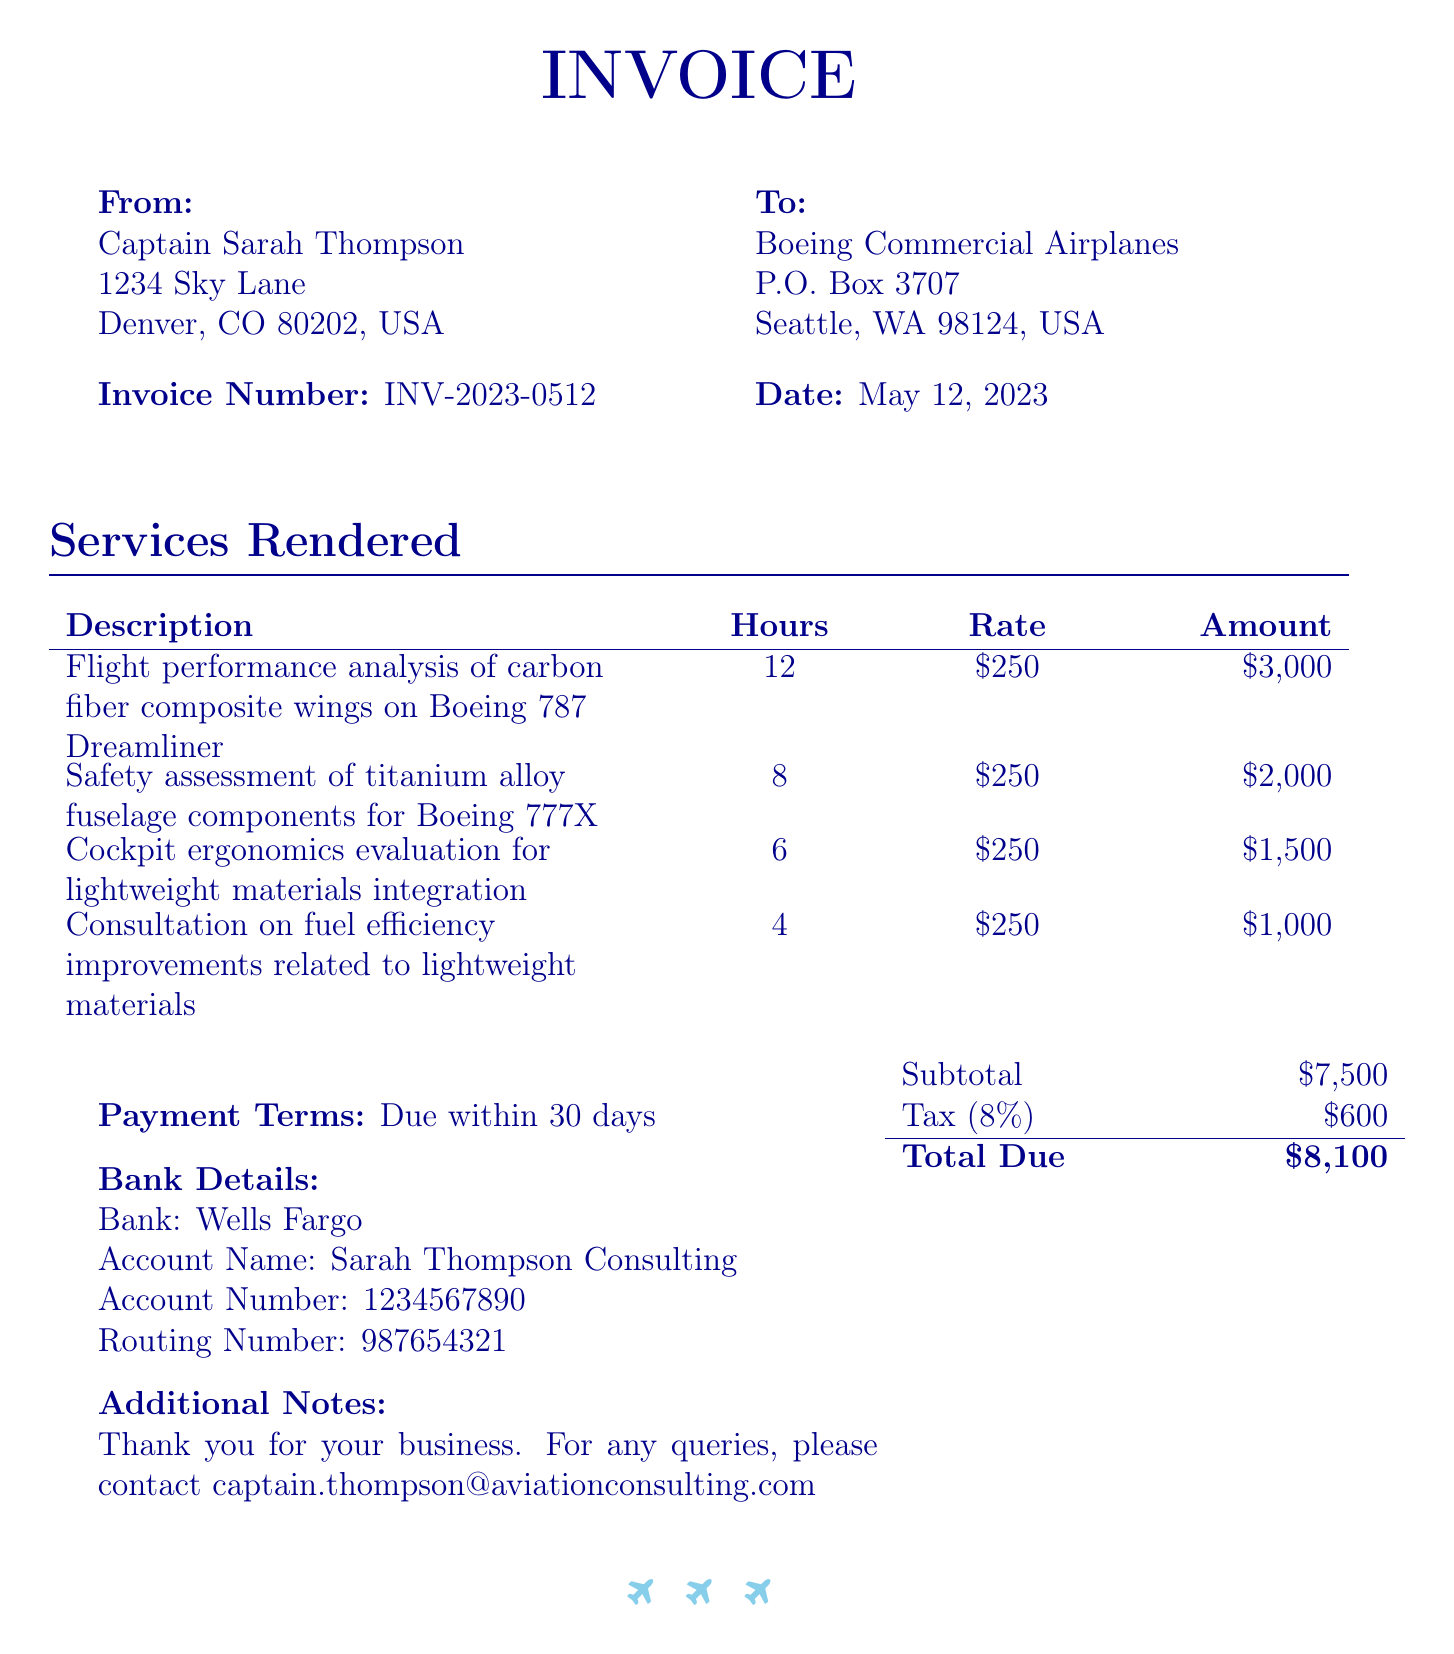What is the invoice number? The invoice number is specified clearly under the "Invoice Number" field in the document.
Answer: INV-2023-0512 Who is the sender of the invoice? The sender details are provided in the "From" section of the invoice, which identifies the individual sending it.
Answer: Captain Sarah Thompson What is the date of the invoice? The date is mentioned under the "Date" field of the invoice, indicating when it was issued.
Answer: May 12, 2023 What is the total amount due? The total amount due is calculated and presented at the bottom of the invoice.
Answer: $8,100 How many hours were spent on flight performance analysis? The number of hours for each service is listed in the services rendered section, specifically for that service.
Answer: 12 What is the tax rate applied to the subtotal? The tax rate is noted in the invoice section detailing the calculations related to the total due.
Answer: 8% What service took the least amount of hours? The hours spent on each service are compared, identifying the one with the lowest value.
Answer: Consultation on fuel efficiency improvements What is the payment term for this invoice? The payment terms are stated in their own section, which specifies the timeframe for payment.
Answer: Due within 30 days What is the total for the safety assessment of titanium alloy fuselage components? The amount for this specific service is directly shown in the services table under its description.
Answer: $2,000 